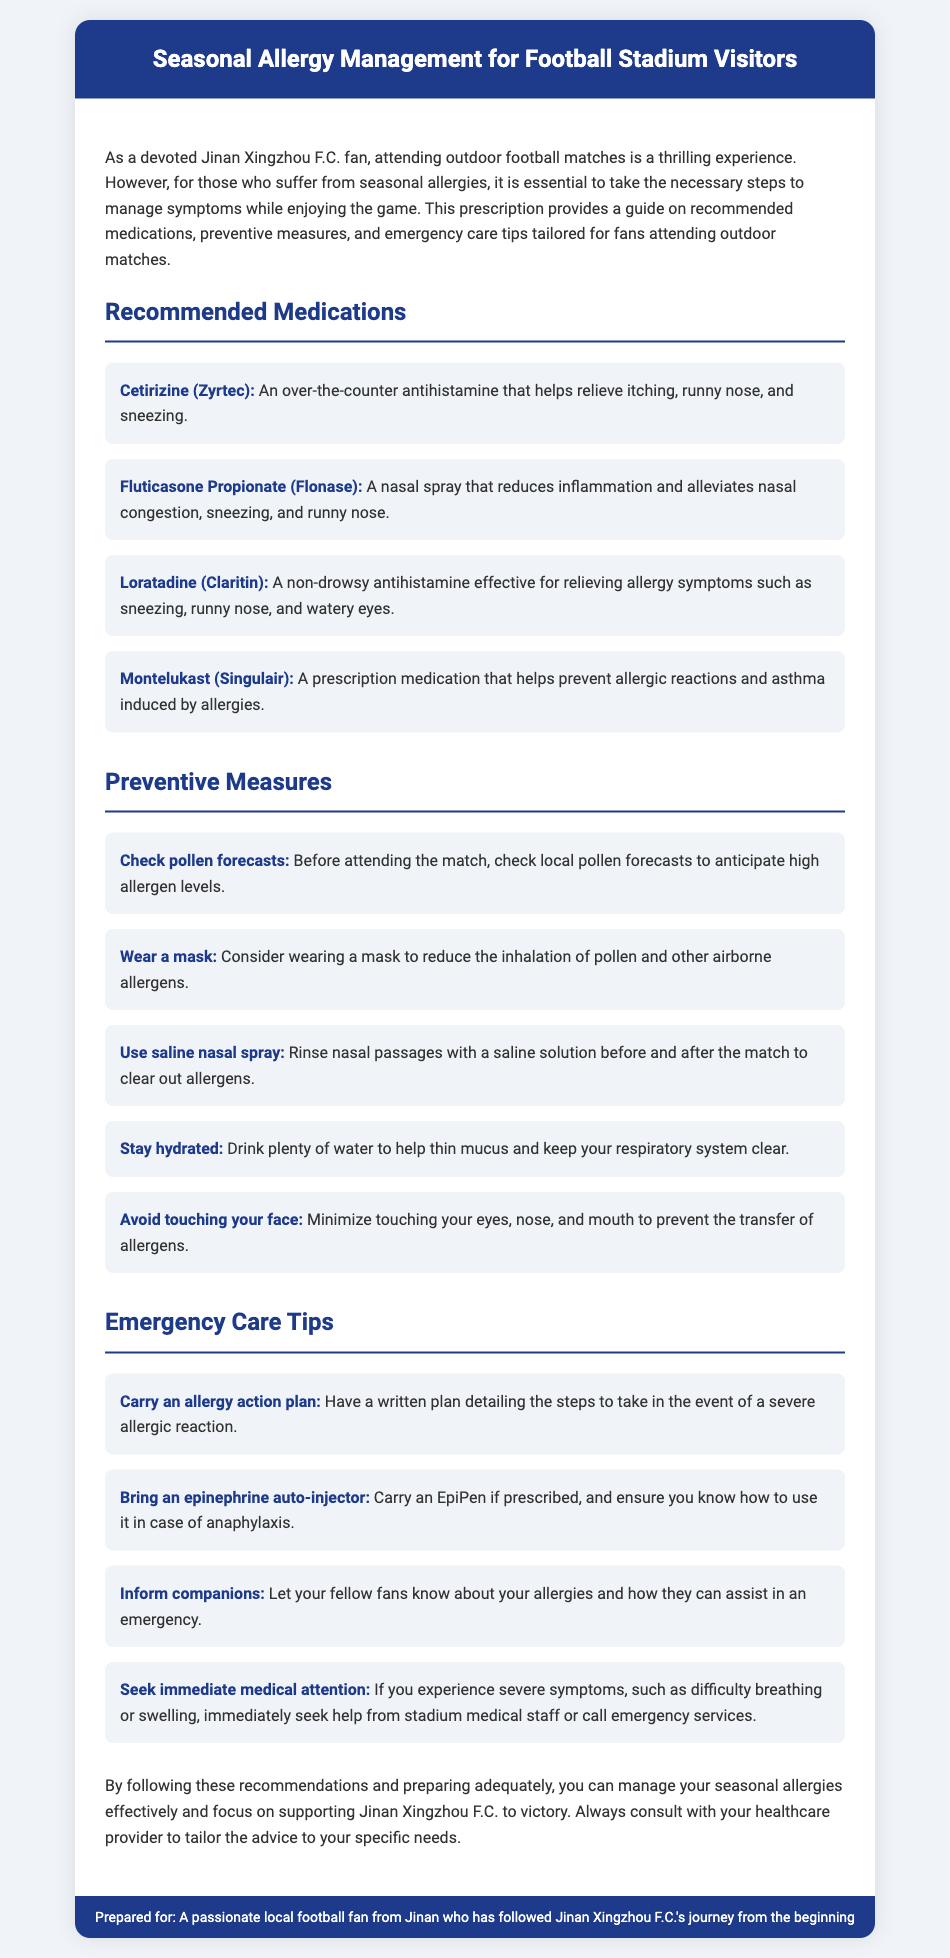What is the name of the recommended antihistamine? The document lists Cetirizine (Zyrtec) as a recommended antihistamine for managing allergies.
Answer: Cetirizine (Zyrtec) What type of medication is Fluticasone Propionate? Fluticasone Propionate is identified as a nasal spray, which is used to reduce inflammation and alleviate nasal congestion.
Answer: Nasal spray How many preventive measures are suggested? The document outlines a total of five preventive measures to help manage seasonal allergies while attending matches.
Answer: Five What should you carry if prescribed for severe allergic reactions? Fans are advised to bring an epinephrine auto-injector (EpiPen) if prescribed for severe allergic reactions.
Answer: Epinephrine auto-injector (EpiPen) What is one way to prepare for attending a match regarding pollen? Checking local pollen forecasts before attending the match is suggested as a preparation step.
Answer: Check local pollen forecasts What does the allergy action plan include? An allergy action plan includes written steps to take in the event of a severe allergic reaction.
Answer: Written steps for severe allergic reactions What is the main goal of the document? The main goal of the document is to help fans manage seasonal allergies while enjoying outdoor football matches.
Answer: Manage seasonal allergies How should you inform others about your allergies? The document suggests informing your fellow fans about your allergies so they can assist in an emergency.
Answer: Inform fellow fans 